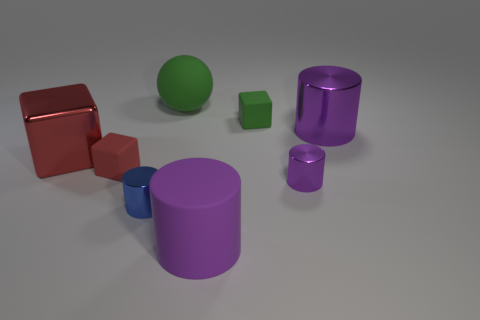How many shiny objects are green cubes or tiny blocks?
Your answer should be very brief. 0. What size is the other metal cylinder that is the same color as the big metallic cylinder?
Provide a short and direct response. Small. What material is the red cube to the left of the small rubber thing in front of the large purple metallic cylinder?
Offer a very short reply. Metal. How many objects are green balls or things right of the small red rubber block?
Provide a short and direct response. 6. There is a block that is made of the same material as the tiny purple cylinder; what is its size?
Offer a very short reply. Large. What number of gray things are either blocks or big cylinders?
Provide a short and direct response. 0. What is the shape of the small thing that is the same color as the large rubber cylinder?
Give a very brief answer. Cylinder. Does the shiny thing on the left side of the small blue metallic object have the same shape as the big purple object to the right of the purple rubber thing?
Make the answer very short. No. How many green blocks are there?
Offer a terse response. 1. The big thing that is the same material as the big green ball is what shape?
Your answer should be compact. Cylinder. 